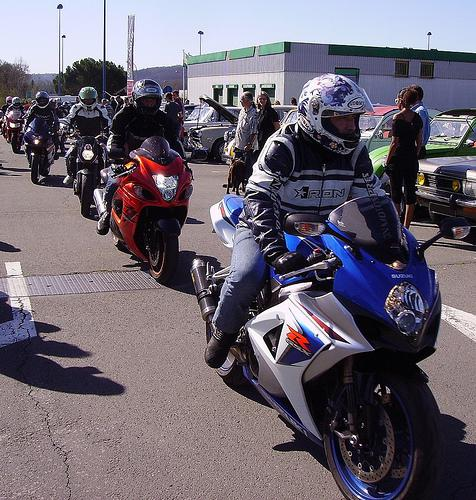Question: who are the guys in the motorcycle gear?
Choices:
A. Men.
B. Motorcyclists.
C. Women.
D. Bankers.
Answer with the letter. Answer: B Question: where are these people?
Choices:
A. At the beach.
B. At the store.
C. Downtown.
D. In the streets.
Answer with the letter. Answer: D Question: what other gear are the motorcyclists wearing for protection?
Choices:
A. Leather jackets.
B. Helmets.
C. Gloves.
D. Vests.
Answer with the letter. Answer: A Question: what are these men wearing to protect their heads?
Choices:
A. Hats.
B. Visors.
C. Cloth.
D. Helmets.
Answer with the letter. Answer: D 